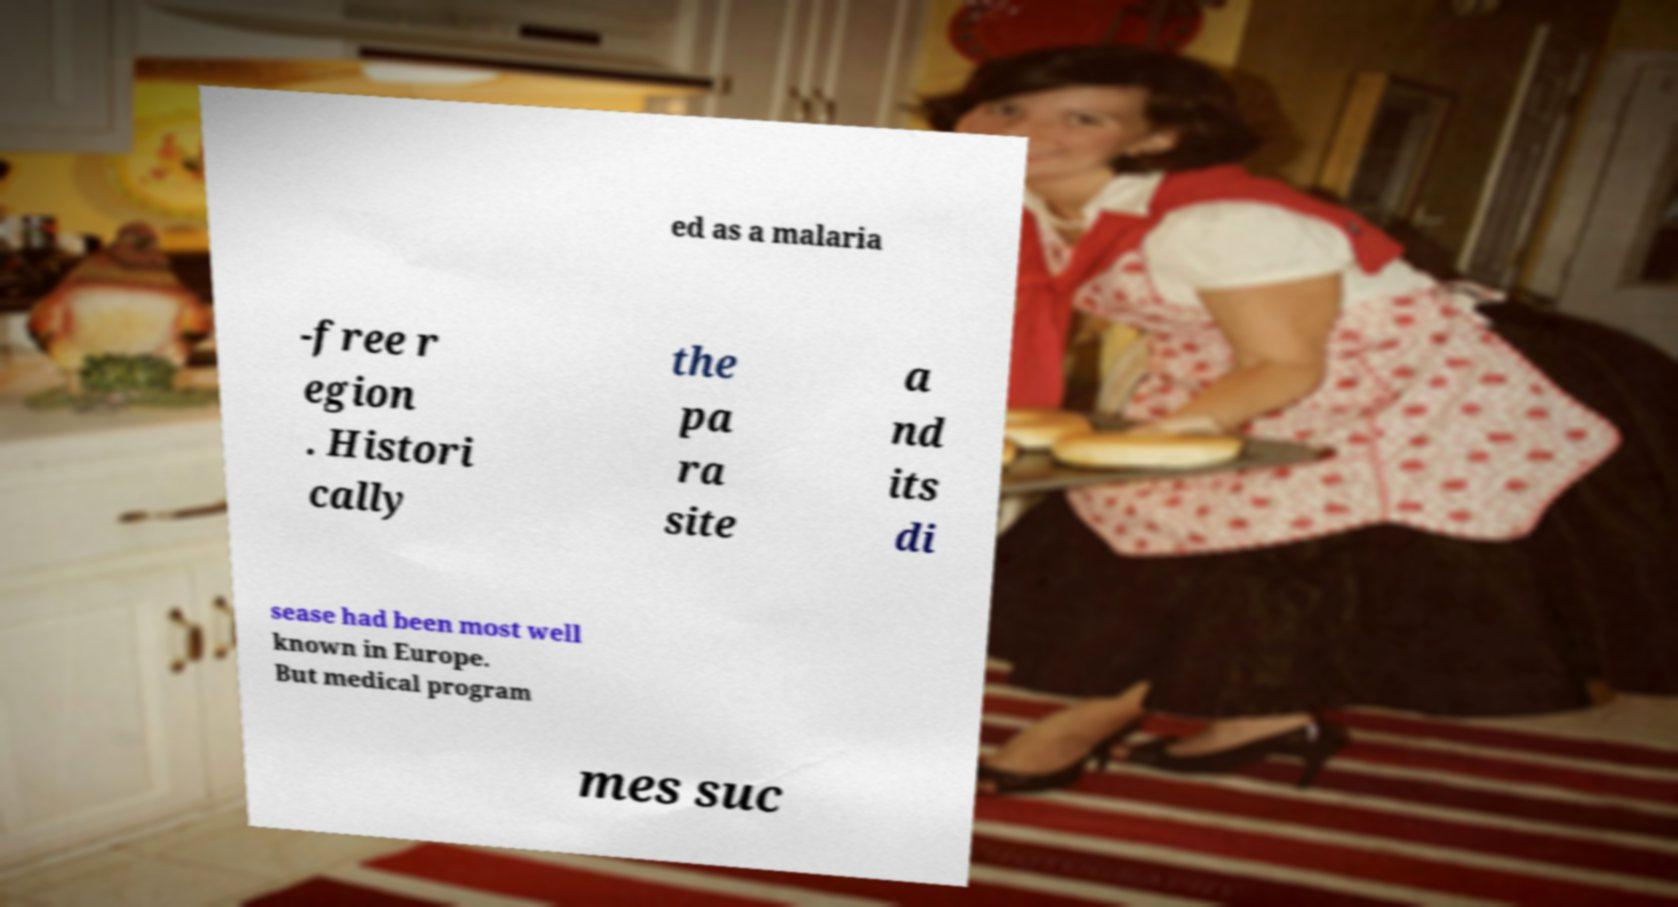Can you accurately transcribe the text from the provided image for me? ed as a malaria -free r egion . Histori cally the pa ra site a nd its di sease had been most well known in Europe. But medical program mes suc 